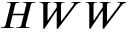<formula> <loc_0><loc_0><loc_500><loc_500>H W W</formula> 